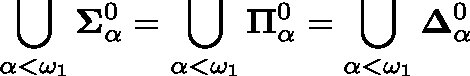Convert formula to latex. <formula><loc_0><loc_0><loc_500><loc_500>\bigcup _ { \alpha < \omega _ { 1 } } \Sigma _ { \alpha } ^ { 0 } = \bigcup _ { \alpha < \omega _ { 1 } } \Pi _ { \alpha } ^ { 0 } = \bigcup _ { \alpha < \omega _ { 1 } } \Delta _ { \alpha } ^ { 0 }</formula> 